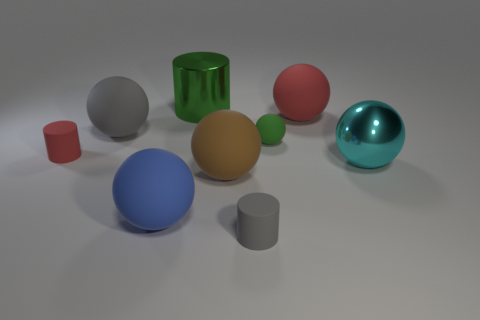Are there any matte spheres of the same color as the large metallic cylinder?
Your answer should be very brief. Yes. Do the big cylinder and the small rubber ball have the same color?
Provide a succinct answer. Yes. Does the metal thing that is left of the cyan shiny object have the same size as the red rubber cylinder?
Offer a terse response. No. Are there fewer tiny things that are in front of the large cyan metallic sphere than big spheres?
Provide a short and direct response. Yes. How big is the matte cylinder behind the small matte cylinder in front of the metal sphere?
Make the answer very short. Small. Is the number of green shiny objects less than the number of big red metal things?
Give a very brief answer. No. There is a large ball that is both in front of the big red rubber ball and on the right side of the brown matte sphere; what is it made of?
Your response must be concise. Metal. Is there a tiny gray matte cylinder on the left side of the gray object in front of the small red matte object?
Your answer should be compact. No. How many things are either big gray balls or big cyan spheres?
Make the answer very short. 2. What is the shape of the large rubber thing that is both in front of the green matte sphere and on the right side of the green cylinder?
Provide a succinct answer. Sphere. 